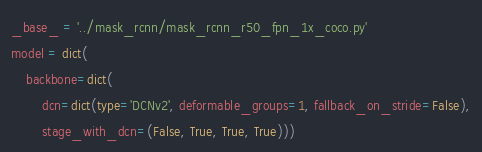Convert code to text. <code><loc_0><loc_0><loc_500><loc_500><_Python_>_base_ = '../mask_rcnn/mask_rcnn_r50_fpn_1x_coco.py'
model = dict(
    backbone=dict(
        dcn=dict(type='DCNv2', deformable_groups=1, fallback_on_stride=False),
        stage_with_dcn=(False, True, True, True)))
</code> 